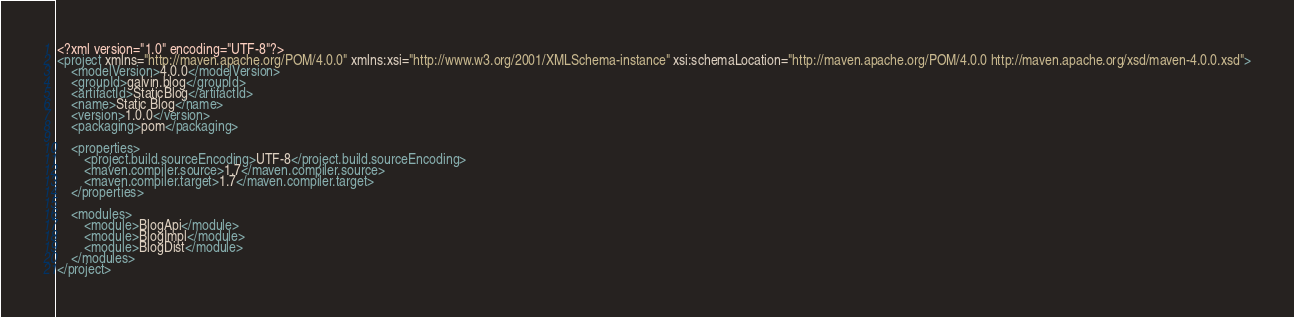Convert code to text. <code><loc_0><loc_0><loc_500><loc_500><_XML_><?xml version="1.0" encoding="UTF-8"?>
<project xmlns="http://maven.apache.org/POM/4.0.0" xmlns:xsi="http://www.w3.org/2001/XMLSchema-instance" xsi:schemaLocation="http://maven.apache.org/POM/4.0.0 http://maven.apache.org/xsd/maven-4.0.0.xsd">
    <modelVersion>4.0.0</modelVersion>
    <groupId>galvin.blog</groupId>
    <artifactId>StaticBlog</artifactId>
    <name>Static Blog</name>
    <version>1.0.0</version>
    <packaging>pom</packaging>
    
    <properties>
        <project.build.sourceEncoding>UTF-8</project.build.sourceEncoding>
        <maven.compiler.source>1.7</maven.compiler.source>
        <maven.compiler.target>1.7</maven.compiler.target>
    </properties>
    
    <modules>
        <module>BlogApi</module>
        <module>BlogImpl</module>
        <module>BlogDist</module>
    </modules>
</project></code> 